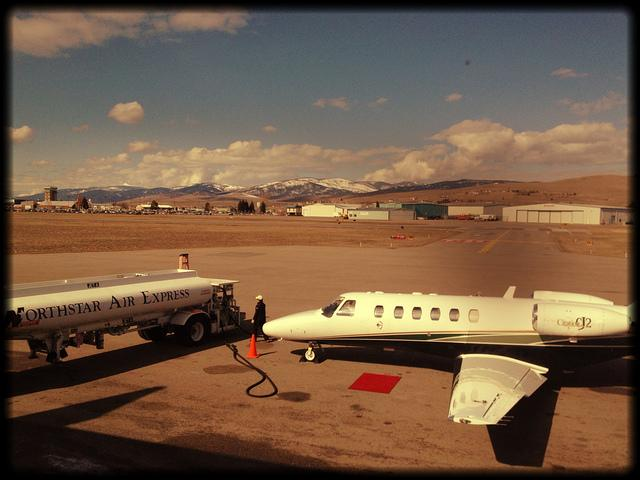What is northstar air express responsible for?

Choices:
A) refueling
B) cleaning
C) luggage
D) maintenance refueling 